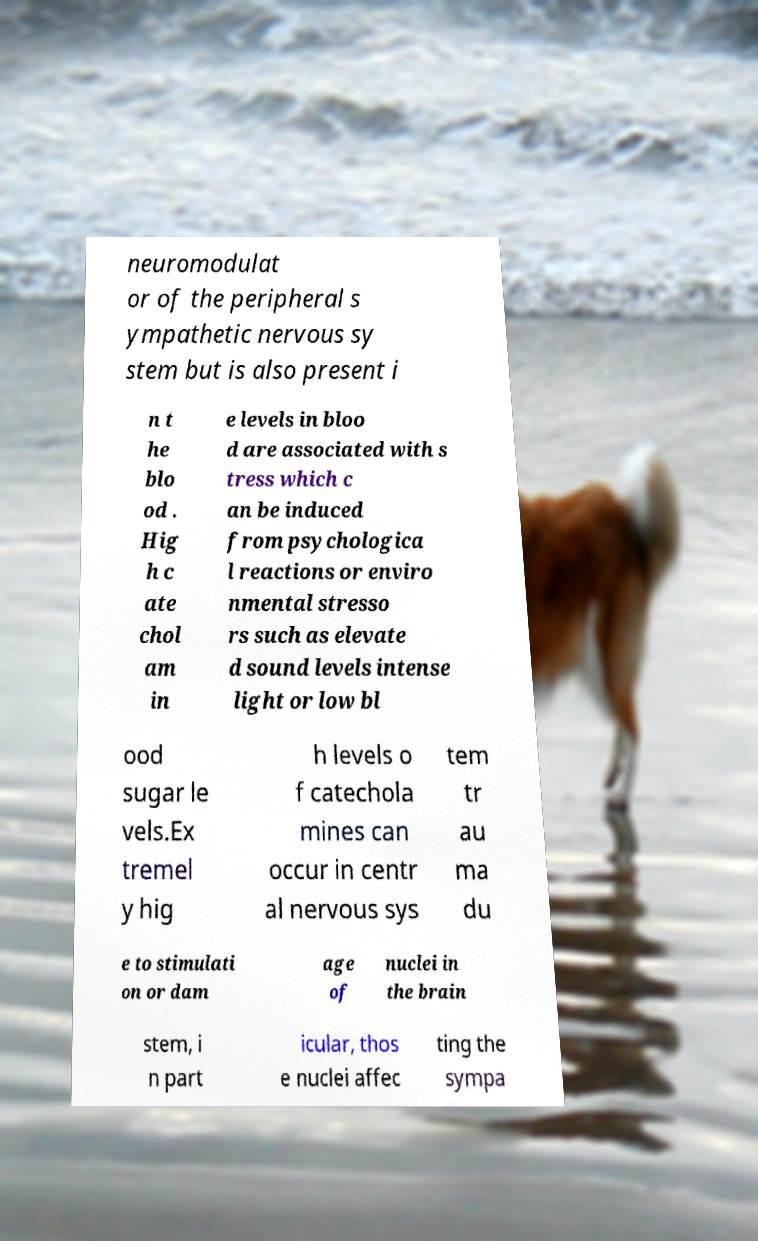Please read and relay the text visible in this image. What does it say? neuromodulat or of the peripheral s ympathetic nervous sy stem but is also present i n t he blo od . Hig h c ate chol am in e levels in bloo d are associated with s tress which c an be induced from psychologica l reactions or enviro nmental stresso rs such as elevate d sound levels intense light or low bl ood sugar le vels.Ex tremel y hig h levels o f catechola mines can occur in centr al nervous sys tem tr au ma du e to stimulati on or dam age of nuclei in the brain stem, i n part icular, thos e nuclei affec ting the sympa 